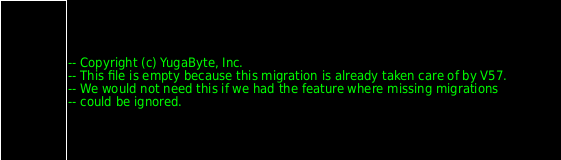Convert code to text. <code><loc_0><loc_0><loc_500><loc_500><_SQL_>-- Copyright (c) YugaByte, Inc.
-- This file is empty because this migration is already taken care of by V57.
-- We would not need this if we had the feature where missing migrations
-- could be ignored.
</code> 